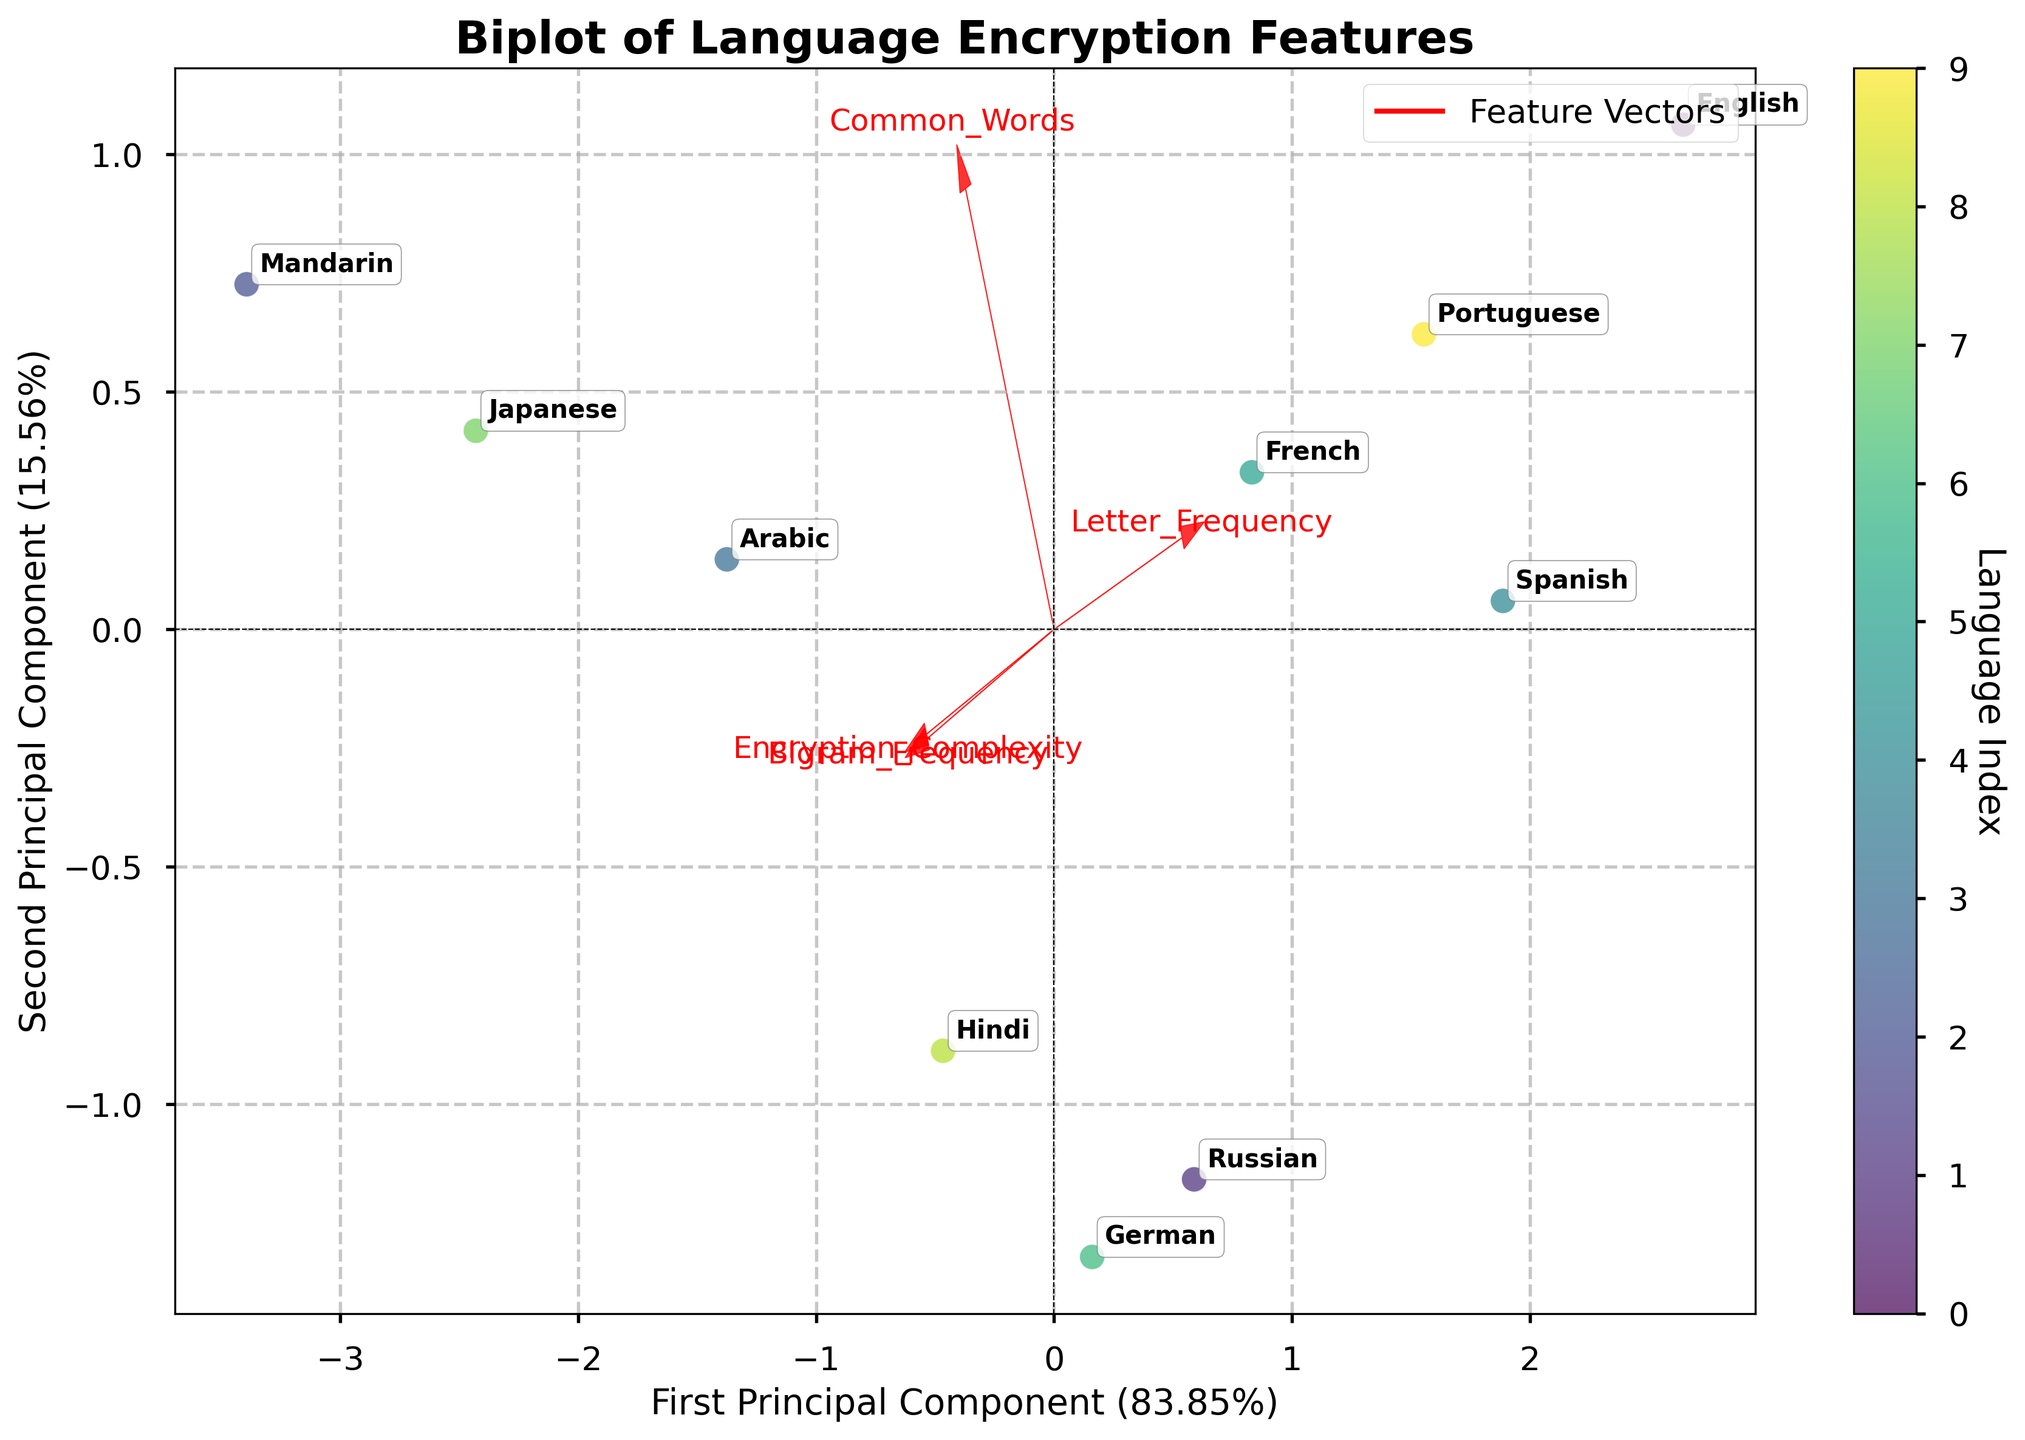What is the title of the biplot? The title of the biplot is written prominently at the top of the figure. The words used describe the biplot's focus.
Answer: Biplot of Language Encryption Features How many languages are represented in the plot? Each language is plotted as a point on the biplot. Counting the different points with labels gives us the total number of languages.
Answer: 10 Which two languages are closest to each other in the biplot? By visually inspecting the scatter, Spanish and Portuguese are closest to each other, indicating similar properties in the PCA space.
Answer: Spanish and Portuguese Which feature vector has the largest magnitude? The feature vectors are represented by arrows. The length of each arrow indicates the magnitude. By comparing, 'Common_Words' appears longest.
Answer: Common_Words How much variance is explained by the first principal component? The percentage of variance explained is labeled on the x-axis as part of the biplot. The exact figure is given in the axis label.
Answer: 53.29% How are Mandarin and Arabic positioned relative to the second principal component? Mandarin is above the origin while Arabic is slightly below along the y-axis, meaning Mandarin has a higher second component value. Comparing their y-values reveals their relative positioning.
Answer: Mandarin is higher Which language lies closest to the origin, and what might this imply? The plot point closest to the origin is identified visually. Being close to the origin can imply average values in all feature dimensions.
Answer: English Are "Letter_Frequency" and "Common_Words" positively correlated in this PCA? Positive correlation in PCA is represented by feature arrows pointing in similar directions. 'Letter_Frequency' and 'Common_Words' arrows point in different directions, showing a lack of correlation.
Answer: No, they are not What can you infer about languages that lie in the direction of the "Encryption_Complexity" vector? These languages have higher scores along the 'Encryption_Complexity' vector in the original data, indicating a higher complexity of encryption. Japanese, Arabic, and Mandarin lie in this direction.
Answer: Higher encryption complexity 